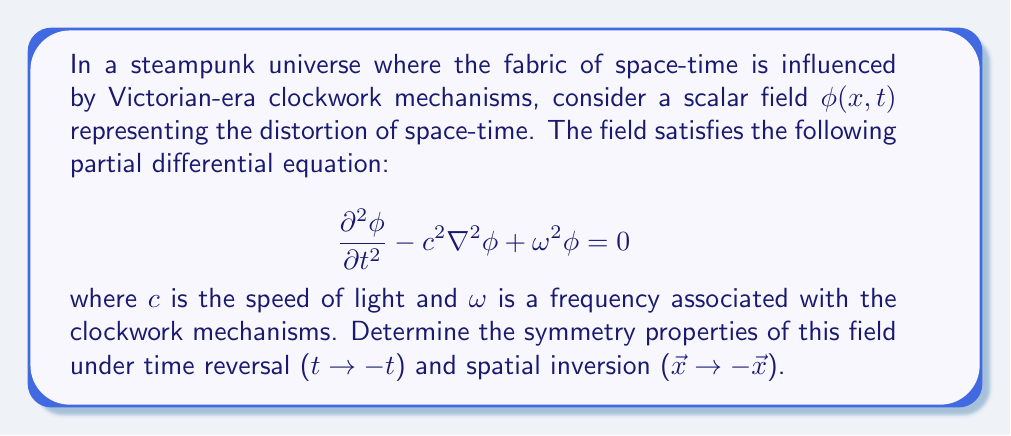Solve this math problem. To determine the symmetry properties of the field, we need to examine how the equation transforms under time reversal and spatial inversion:

1. Time reversal symmetry:
   Let $t' = -t$. We need to check if $\phi(x,-t)$ satisfies the equation.
   
   a) $\frac{\partial^2\phi}{\partial t^2} \to \frac{\partial^2\phi}{\partial {t'}^2}$ (unchanged)
   b) $\nabla^2\phi$ is unchanged as it only involves spatial derivatives
   c) $\omega^2\phi$ is unchanged
   
   The equation remains the same under $t \to -t$, so the field has time reversal symmetry.

2. Spatial inversion symmetry:
   Let $\vec{x'} = -\vec{x}$. We need to check if $\phi(-x,t)$ satisfies the equation.
   
   a) $\frac{\partial^2\phi}{\partial t^2}$ is unchanged as it only involves time derivatives
   b) $\nabla^2\phi \to \nabla^2\phi$ (unchanged, as $\nabla^2$ involves second-order spatial derivatives)
   c) $\omega^2\phi$ is unchanged
   
   The equation remains the same under $\vec{x} \to -\vec{x}$, so the field has spatial inversion symmetry.

Therefore, the field $\phi(x,t)$ possesses both time reversal and spatial inversion symmetry, which means it is invariant under these transformations.
Answer: The field $\phi(x,t)$ is symmetric under both time reversal and spatial inversion. 